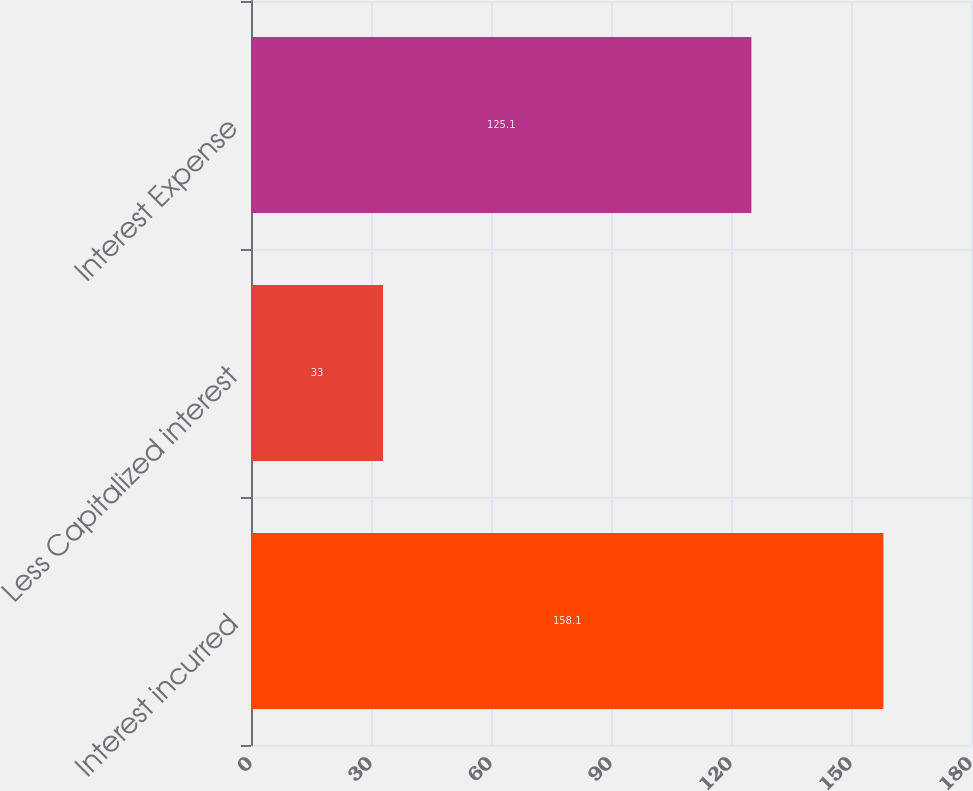Convert chart. <chart><loc_0><loc_0><loc_500><loc_500><bar_chart><fcel>Interest incurred<fcel>Less Capitalized interest<fcel>Interest Expense<nl><fcel>158.1<fcel>33<fcel>125.1<nl></chart> 